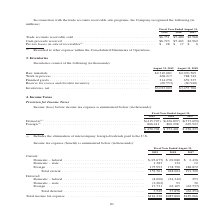From Jabil Circuit's financial document, Which years does the table provide information for inventories? The document shows two values: 2019 and 2018. From the document: "2019 2018 2017 2019 2018 2017..." Also, What was the amount of finished goods in 2019? According to the financial document, 314,258 (in thousands). The relevant text states: "ork in process . 468,217 788,742 Finished goods . 314,258 659,335 Reserve for excess and obsolete inventory . (69,553) (60,940)..." Also, What was the amount of work in process in 2018? According to the financial document, 788,742 (in thousands). The relevant text states: ". $2,310,081 $2,070,569 Work in process . 468,217 788,742 Finished goods . 314,258 659,335 Reserve for excess and obsolete inventory . (69,553) (60,940)..." Also, can you calculate: What was the change in finished goods between 2018 and 2019? Based on the calculation: 314,258-659,335, the result is -345077 (in thousands). This is based on the information: "rocess . 468,217 788,742 Finished goods . 314,258 659,335 Reserve for excess and obsolete inventory . (69,553) (60,940) ork in process . 468,217 788,742 Finished goods . 314,258 659,335 Reserve for ex..." The key data points involved are: 314,258, 659,335. Also, can you calculate: What was the change in work in process between 2018 and 2019? Based on the calculation: 468,217-788,742, the result is -320525 (in thousands). This is based on the information: ". $2,310,081 $2,070,569 Work in process . 468,217 788,742 Finished goods . 314,258 659,335 Reserve for excess and obsolete inventory . (69,553) (60,940) terials . $2,310,081 $2,070,569 Work in process..." The key data points involved are: 468,217, 788,742. Also, can you calculate: What was the percentage change in raw materials between 2018 and 2019? To answer this question, I need to perform calculations using the financial data. The calculation is: ($2,310,081-$2,070,569)/$2,070,569, which equals 11.57 (percentage). This is based on the information: "Raw materials . $2,310,081 $2,070,569 Work in process . 468,217 788,742 Finished goods . 314,258 659,335 Reserve for excess an Raw materials . $2,310,081 $2,070,569 Work in process . 468,217 788,742 F..." The key data points involved are: 2,070,569, 2,310,081. 